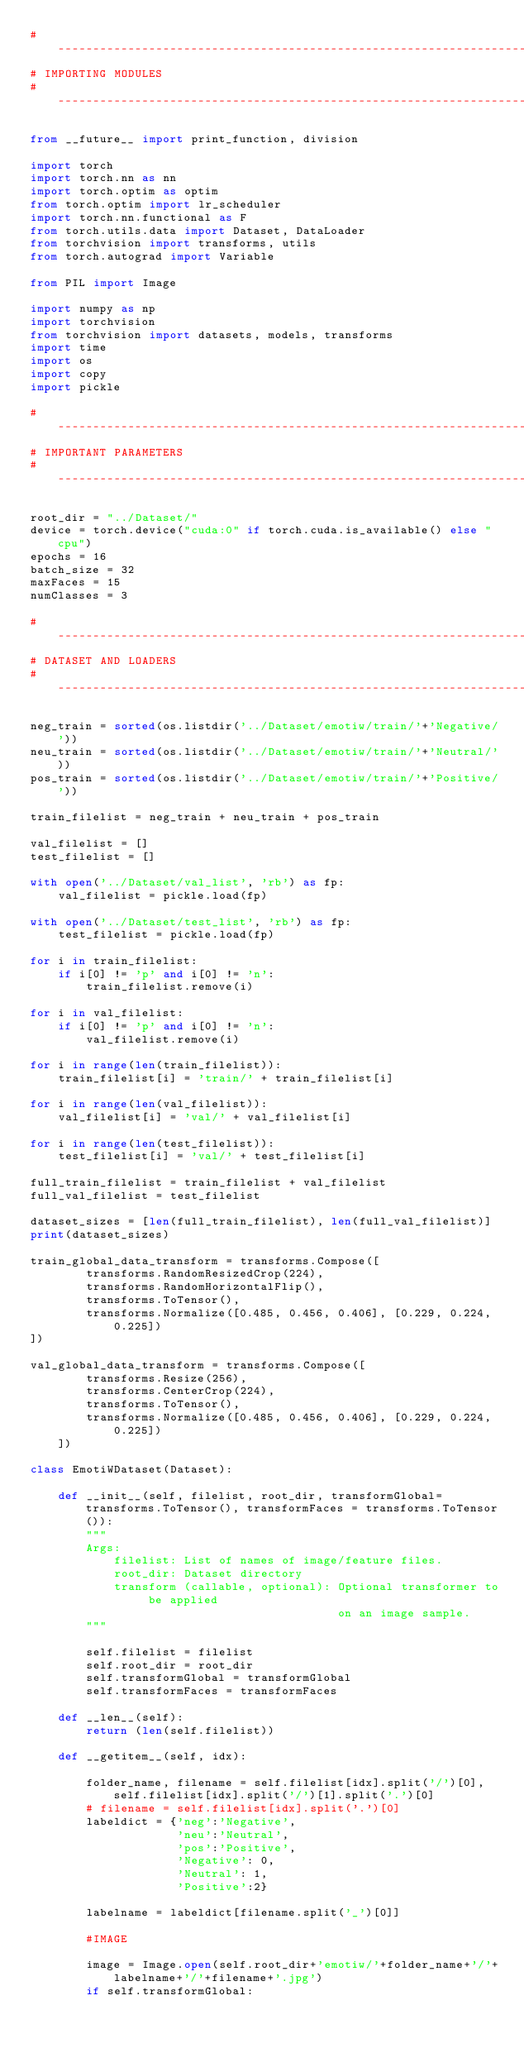Convert code to text. <code><loc_0><loc_0><loc_500><loc_500><_Python_>#----------------------------------------------------------------------------
# IMPORTING MODULES
#----------------------------------------------------------------------------

from __future__ import print_function, division

import torch
import torch.nn as nn
import torch.optim as optim
from torch.optim import lr_scheduler
import torch.nn.functional as F
from torch.utils.data import Dataset, DataLoader
from torchvision import transforms, utils
from torch.autograd import Variable

from PIL import Image

import numpy as np
import torchvision
from torchvision import datasets, models, transforms
import time
import os
import copy
import pickle

#---------------------------------------------------------------------------
# IMPORTANT PARAMETERS
#---------------------------------------------------------------------------

root_dir = "../Dataset/"
device = torch.device("cuda:0" if torch.cuda.is_available() else "cpu")
epochs = 16
batch_size = 32
maxFaces = 15
numClasses = 3

#---------------------------------------------------------------------------
# DATASET AND LOADERS
#---------------------------------------------------------------------------

neg_train = sorted(os.listdir('../Dataset/emotiw/train/'+'Negative/'))
neu_train = sorted(os.listdir('../Dataset/emotiw/train/'+'Neutral/'))
pos_train = sorted(os.listdir('../Dataset/emotiw/train/'+'Positive/'))

train_filelist = neg_train + neu_train + pos_train

val_filelist = []
test_filelist = []

with open('../Dataset/val_list', 'rb') as fp:
    val_filelist = pickle.load(fp)

with open('../Dataset/test_list', 'rb') as fp:
    test_filelist = pickle.load(fp)

for i in train_filelist:
    if i[0] != 'p' and i[0] != 'n':
        train_filelist.remove(i)
        
for i in val_filelist:
    if i[0] != 'p' and i[0] != 'n':
        val_filelist.remove(i)

for i in range(len(train_filelist)):
    train_filelist[i] = 'train/' + train_filelist[i]

for i in range(len(val_filelist)):
    val_filelist[i] = 'val/' + val_filelist[i]

for i in range(len(test_filelist)):
    test_filelist[i] = 'val/' + test_filelist[i]

full_train_filelist = train_filelist + val_filelist
full_val_filelist = test_filelist

dataset_sizes = [len(full_train_filelist), len(full_val_filelist)]
print(dataset_sizes)

train_global_data_transform = transforms.Compose([
        transforms.RandomResizedCrop(224),
        transforms.RandomHorizontalFlip(),
        transforms.ToTensor(),
        transforms.Normalize([0.485, 0.456, 0.406], [0.229, 0.224, 0.225])
])

val_global_data_transform = transforms.Compose([
        transforms.Resize(256),
        transforms.CenterCrop(224),
        transforms.ToTensor(),
        transforms.Normalize([0.485, 0.456, 0.406], [0.229, 0.224, 0.225])
    ])

class EmotiWDataset(Dataset):
    
    def __init__(self, filelist, root_dir, transformGlobal=transforms.ToTensor(), transformFaces = transforms.ToTensor()):
        """
        Args:
            filelist: List of names of image/feature files.
            root_dir: Dataset directory
            transform (callable, optional): Optional transformer to be applied
                                            on an image sample.
        """
        
        self.filelist = filelist
        self.root_dir = root_dir
        self.transformGlobal = transformGlobal
        self.transformFaces = transformFaces
            
    def __len__(self):
        return (len(self.filelist)) 
 
    def __getitem__(self, idx):
        
        folder_name, filename = self.filelist[idx].split('/')[0], self.filelist[idx].split('/')[1].split('.')[0]
        # filename = self.filelist[idx].split('.')[0]
        labeldict = {'neg':'Negative',
                     'neu':'Neutral',
                     'pos':'Positive',
                     'Negative': 0,
                     'Neutral': 1,
                     'Positive':2}

        labelname = labeldict[filename.split('_')[0]]

        #IMAGE 

        image = Image.open(self.root_dir+'emotiw/'+folder_name+'/'+labelname+'/'+filename+'.jpg')
        if self.transformGlobal:</code> 